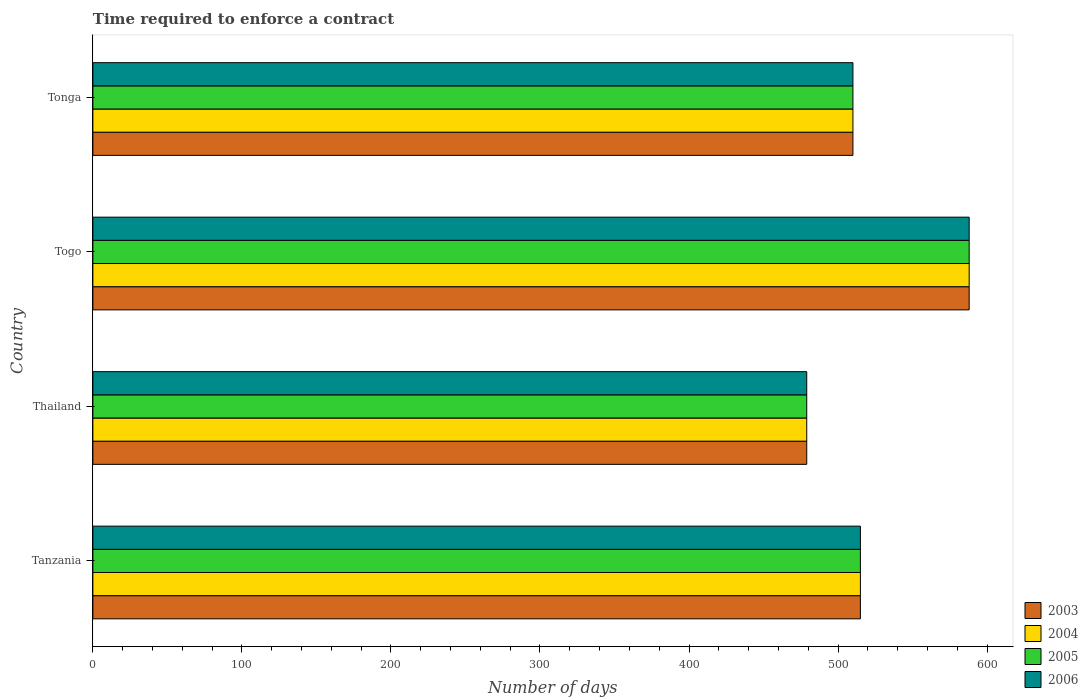Are the number of bars per tick equal to the number of legend labels?
Make the answer very short. Yes. How many bars are there on the 1st tick from the top?
Your answer should be very brief. 4. How many bars are there on the 3rd tick from the bottom?
Offer a terse response. 4. What is the label of the 1st group of bars from the top?
Ensure brevity in your answer.  Tonga. What is the number of days required to enforce a contract in 2003 in Togo?
Ensure brevity in your answer.  588. Across all countries, what is the maximum number of days required to enforce a contract in 2006?
Offer a terse response. 588. Across all countries, what is the minimum number of days required to enforce a contract in 2005?
Provide a short and direct response. 479. In which country was the number of days required to enforce a contract in 2005 maximum?
Offer a very short reply. Togo. In which country was the number of days required to enforce a contract in 2005 minimum?
Your response must be concise. Thailand. What is the total number of days required to enforce a contract in 2004 in the graph?
Provide a short and direct response. 2092. What is the average number of days required to enforce a contract in 2003 per country?
Offer a terse response. 523. What is the difference between the number of days required to enforce a contract in 2005 and number of days required to enforce a contract in 2004 in Tonga?
Keep it short and to the point. 0. What is the ratio of the number of days required to enforce a contract in 2006 in Tanzania to that in Tonga?
Your answer should be very brief. 1.01. Is the number of days required to enforce a contract in 2003 in Tanzania less than that in Thailand?
Make the answer very short. No. Is the difference between the number of days required to enforce a contract in 2005 in Tanzania and Tonga greater than the difference between the number of days required to enforce a contract in 2004 in Tanzania and Tonga?
Ensure brevity in your answer.  No. What is the difference between the highest and the lowest number of days required to enforce a contract in 2004?
Offer a very short reply. 109. In how many countries, is the number of days required to enforce a contract in 2004 greater than the average number of days required to enforce a contract in 2004 taken over all countries?
Your answer should be compact. 1. Is the sum of the number of days required to enforce a contract in 2006 in Togo and Tonga greater than the maximum number of days required to enforce a contract in 2005 across all countries?
Offer a terse response. Yes. Is it the case that in every country, the sum of the number of days required to enforce a contract in 2003 and number of days required to enforce a contract in 2006 is greater than the sum of number of days required to enforce a contract in 2004 and number of days required to enforce a contract in 2005?
Offer a very short reply. No. What does the 4th bar from the top in Tanzania represents?
Offer a terse response. 2003. What does the 3rd bar from the bottom in Tanzania represents?
Your response must be concise. 2005. Are all the bars in the graph horizontal?
Make the answer very short. Yes. How many countries are there in the graph?
Your answer should be compact. 4. What is the difference between two consecutive major ticks on the X-axis?
Your response must be concise. 100. Does the graph contain grids?
Give a very brief answer. No. Where does the legend appear in the graph?
Your answer should be compact. Bottom right. How many legend labels are there?
Provide a succinct answer. 4. What is the title of the graph?
Provide a succinct answer. Time required to enforce a contract. What is the label or title of the X-axis?
Your response must be concise. Number of days. What is the Number of days in 2003 in Tanzania?
Provide a succinct answer. 515. What is the Number of days in 2004 in Tanzania?
Ensure brevity in your answer.  515. What is the Number of days in 2005 in Tanzania?
Give a very brief answer. 515. What is the Number of days in 2006 in Tanzania?
Offer a very short reply. 515. What is the Number of days of 2003 in Thailand?
Your response must be concise. 479. What is the Number of days of 2004 in Thailand?
Your answer should be very brief. 479. What is the Number of days in 2005 in Thailand?
Your answer should be compact. 479. What is the Number of days in 2006 in Thailand?
Your answer should be compact. 479. What is the Number of days in 2003 in Togo?
Give a very brief answer. 588. What is the Number of days of 2004 in Togo?
Keep it short and to the point. 588. What is the Number of days in 2005 in Togo?
Make the answer very short. 588. What is the Number of days of 2006 in Togo?
Offer a terse response. 588. What is the Number of days in 2003 in Tonga?
Give a very brief answer. 510. What is the Number of days of 2004 in Tonga?
Provide a short and direct response. 510. What is the Number of days in 2005 in Tonga?
Your answer should be compact. 510. What is the Number of days in 2006 in Tonga?
Provide a succinct answer. 510. Across all countries, what is the maximum Number of days of 2003?
Offer a terse response. 588. Across all countries, what is the maximum Number of days of 2004?
Your answer should be compact. 588. Across all countries, what is the maximum Number of days of 2005?
Offer a terse response. 588. Across all countries, what is the maximum Number of days in 2006?
Your answer should be very brief. 588. Across all countries, what is the minimum Number of days of 2003?
Offer a very short reply. 479. Across all countries, what is the minimum Number of days of 2004?
Keep it short and to the point. 479. Across all countries, what is the minimum Number of days of 2005?
Your response must be concise. 479. Across all countries, what is the minimum Number of days of 2006?
Make the answer very short. 479. What is the total Number of days of 2003 in the graph?
Offer a terse response. 2092. What is the total Number of days in 2004 in the graph?
Offer a terse response. 2092. What is the total Number of days in 2005 in the graph?
Offer a terse response. 2092. What is the total Number of days of 2006 in the graph?
Provide a short and direct response. 2092. What is the difference between the Number of days in 2004 in Tanzania and that in Thailand?
Provide a succinct answer. 36. What is the difference between the Number of days in 2005 in Tanzania and that in Thailand?
Your response must be concise. 36. What is the difference between the Number of days in 2003 in Tanzania and that in Togo?
Your answer should be compact. -73. What is the difference between the Number of days in 2004 in Tanzania and that in Togo?
Ensure brevity in your answer.  -73. What is the difference between the Number of days of 2005 in Tanzania and that in Togo?
Your response must be concise. -73. What is the difference between the Number of days in 2006 in Tanzania and that in Togo?
Offer a very short reply. -73. What is the difference between the Number of days of 2003 in Tanzania and that in Tonga?
Your answer should be very brief. 5. What is the difference between the Number of days of 2004 in Tanzania and that in Tonga?
Provide a succinct answer. 5. What is the difference between the Number of days in 2005 in Tanzania and that in Tonga?
Keep it short and to the point. 5. What is the difference between the Number of days in 2006 in Tanzania and that in Tonga?
Make the answer very short. 5. What is the difference between the Number of days of 2003 in Thailand and that in Togo?
Ensure brevity in your answer.  -109. What is the difference between the Number of days in 2004 in Thailand and that in Togo?
Keep it short and to the point. -109. What is the difference between the Number of days in 2005 in Thailand and that in Togo?
Offer a terse response. -109. What is the difference between the Number of days of 2006 in Thailand and that in Togo?
Provide a short and direct response. -109. What is the difference between the Number of days of 2003 in Thailand and that in Tonga?
Provide a short and direct response. -31. What is the difference between the Number of days of 2004 in Thailand and that in Tonga?
Provide a succinct answer. -31. What is the difference between the Number of days of 2005 in Thailand and that in Tonga?
Your response must be concise. -31. What is the difference between the Number of days of 2006 in Thailand and that in Tonga?
Offer a very short reply. -31. What is the difference between the Number of days of 2004 in Togo and that in Tonga?
Provide a short and direct response. 78. What is the difference between the Number of days of 2005 in Togo and that in Tonga?
Ensure brevity in your answer.  78. What is the difference between the Number of days of 2003 in Tanzania and the Number of days of 2004 in Thailand?
Ensure brevity in your answer.  36. What is the difference between the Number of days in 2003 in Tanzania and the Number of days in 2005 in Thailand?
Your answer should be very brief. 36. What is the difference between the Number of days in 2003 in Tanzania and the Number of days in 2004 in Togo?
Make the answer very short. -73. What is the difference between the Number of days of 2003 in Tanzania and the Number of days of 2005 in Togo?
Your answer should be compact. -73. What is the difference between the Number of days of 2003 in Tanzania and the Number of days of 2006 in Togo?
Your answer should be very brief. -73. What is the difference between the Number of days in 2004 in Tanzania and the Number of days in 2005 in Togo?
Provide a succinct answer. -73. What is the difference between the Number of days in 2004 in Tanzania and the Number of days in 2006 in Togo?
Provide a succinct answer. -73. What is the difference between the Number of days in 2005 in Tanzania and the Number of days in 2006 in Togo?
Provide a succinct answer. -73. What is the difference between the Number of days in 2003 in Tanzania and the Number of days in 2004 in Tonga?
Make the answer very short. 5. What is the difference between the Number of days of 2003 in Tanzania and the Number of days of 2006 in Tonga?
Provide a succinct answer. 5. What is the difference between the Number of days in 2003 in Thailand and the Number of days in 2004 in Togo?
Ensure brevity in your answer.  -109. What is the difference between the Number of days of 2003 in Thailand and the Number of days of 2005 in Togo?
Give a very brief answer. -109. What is the difference between the Number of days in 2003 in Thailand and the Number of days in 2006 in Togo?
Offer a very short reply. -109. What is the difference between the Number of days of 2004 in Thailand and the Number of days of 2005 in Togo?
Make the answer very short. -109. What is the difference between the Number of days in 2004 in Thailand and the Number of days in 2006 in Togo?
Offer a terse response. -109. What is the difference between the Number of days in 2005 in Thailand and the Number of days in 2006 in Togo?
Ensure brevity in your answer.  -109. What is the difference between the Number of days in 2003 in Thailand and the Number of days in 2004 in Tonga?
Your answer should be compact. -31. What is the difference between the Number of days of 2003 in Thailand and the Number of days of 2005 in Tonga?
Make the answer very short. -31. What is the difference between the Number of days of 2003 in Thailand and the Number of days of 2006 in Tonga?
Keep it short and to the point. -31. What is the difference between the Number of days in 2004 in Thailand and the Number of days in 2005 in Tonga?
Ensure brevity in your answer.  -31. What is the difference between the Number of days of 2004 in Thailand and the Number of days of 2006 in Tonga?
Provide a short and direct response. -31. What is the difference between the Number of days in 2005 in Thailand and the Number of days in 2006 in Tonga?
Provide a short and direct response. -31. What is the difference between the Number of days in 2003 in Togo and the Number of days in 2004 in Tonga?
Your answer should be very brief. 78. What is the difference between the Number of days of 2004 in Togo and the Number of days of 2005 in Tonga?
Your answer should be very brief. 78. What is the difference between the Number of days of 2004 in Togo and the Number of days of 2006 in Tonga?
Your answer should be compact. 78. What is the average Number of days in 2003 per country?
Provide a succinct answer. 523. What is the average Number of days in 2004 per country?
Your answer should be very brief. 523. What is the average Number of days in 2005 per country?
Give a very brief answer. 523. What is the average Number of days of 2006 per country?
Offer a terse response. 523. What is the difference between the Number of days in 2003 and Number of days in 2005 in Tanzania?
Provide a succinct answer. 0. What is the difference between the Number of days of 2003 and Number of days of 2006 in Tanzania?
Your answer should be compact. 0. What is the difference between the Number of days of 2004 and Number of days of 2005 in Tanzania?
Keep it short and to the point. 0. What is the difference between the Number of days in 2004 and Number of days in 2006 in Tanzania?
Make the answer very short. 0. What is the difference between the Number of days in 2005 and Number of days in 2006 in Tanzania?
Your response must be concise. 0. What is the difference between the Number of days of 2003 and Number of days of 2004 in Thailand?
Offer a very short reply. 0. What is the difference between the Number of days in 2004 and Number of days in 2005 in Thailand?
Your answer should be compact. 0. What is the difference between the Number of days in 2004 and Number of days in 2006 in Thailand?
Provide a succinct answer. 0. What is the difference between the Number of days in 2005 and Number of days in 2006 in Thailand?
Ensure brevity in your answer.  0. What is the difference between the Number of days in 2003 and Number of days in 2005 in Togo?
Offer a very short reply. 0. What is the difference between the Number of days in 2003 and Number of days in 2006 in Togo?
Give a very brief answer. 0. What is the difference between the Number of days in 2003 and Number of days in 2004 in Tonga?
Provide a succinct answer. 0. What is the difference between the Number of days in 2003 and Number of days in 2005 in Tonga?
Keep it short and to the point. 0. What is the difference between the Number of days of 2004 and Number of days of 2005 in Tonga?
Make the answer very short. 0. What is the difference between the Number of days in 2004 and Number of days in 2006 in Tonga?
Your response must be concise. 0. What is the difference between the Number of days of 2005 and Number of days of 2006 in Tonga?
Give a very brief answer. 0. What is the ratio of the Number of days of 2003 in Tanzania to that in Thailand?
Your response must be concise. 1.08. What is the ratio of the Number of days of 2004 in Tanzania to that in Thailand?
Provide a short and direct response. 1.08. What is the ratio of the Number of days of 2005 in Tanzania to that in Thailand?
Offer a very short reply. 1.08. What is the ratio of the Number of days of 2006 in Tanzania to that in Thailand?
Provide a succinct answer. 1.08. What is the ratio of the Number of days in 2003 in Tanzania to that in Togo?
Give a very brief answer. 0.88. What is the ratio of the Number of days in 2004 in Tanzania to that in Togo?
Make the answer very short. 0.88. What is the ratio of the Number of days in 2005 in Tanzania to that in Togo?
Keep it short and to the point. 0.88. What is the ratio of the Number of days of 2006 in Tanzania to that in Togo?
Offer a very short reply. 0.88. What is the ratio of the Number of days in 2003 in Tanzania to that in Tonga?
Your answer should be compact. 1.01. What is the ratio of the Number of days in 2004 in Tanzania to that in Tonga?
Ensure brevity in your answer.  1.01. What is the ratio of the Number of days of 2005 in Tanzania to that in Tonga?
Keep it short and to the point. 1.01. What is the ratio of the Number of days in 2006 in Tanzania to that in Tonga?
Offer a terse response. 1.01. What is the ratio of the Number of days of 2003 in Thailand to that in Togo?
Your answer should be compact. 0.81. What is the ratio of the Number of days of 2004 in Thailand to that in Togo?
Offer a very short reply. 0.81. What is the ratio of the Number of days of 2005 in Thailand to that in Togo?
Keep it short and to the point. 0.81. What is the ratio of the Number of days in 2006 in Thailand to that in Togo?
Your answer should be very brief. 0.81. What is the ratio of the Number of days in 2003 in Thailand to that in Tonga?
Keep it short and to the point. 0.94. What is the ratio of the Number of days of 2004 in Thailand to that in Tonga?
Provide a short and direct response. 0.94. What is the ratio of the Number of days in 2005 in Thailand to that in Tonga?
Provide a succinct answer. 0.94. What is the ratio of the Number of days in 2006 in Thailand to that in Tonga?
Offer a very short reply. 0.94. What is the ratio of the Number of days of 2003 in Togo to that in Tonga?
Ensure brevity in your answer.  1.15. What is the ratio of the Number of days of 2004 in Togo to that in Tonga?
Offer a terse response. 1.15. What is the ratio of the Number of days of 2005 in Togo to that in Tonga?
Your response must be concise. 1.15. What is the ratio of the Number of days of 2006 in Togo to that in Tonga?
Offer a very short reply. 1.15. What is the difference between the highest and the second highest Number of days in 2004?
Your answer should be compact. 73. What is the difference between the highest and the second highest Number of days of 2006?
Your answer should be very brief. 73. What is the difference between the highest and the lowest Number of days of 2003?
Your answer should be very brief. 109. What is the difference between the highest and the lowest Number of days in 2004?
Your answer should be compact. 109. What is the difference between the highest and the lowest Number of days in 2005?
Your answer should be compact. 109. What is the difference between the highest and the lowest Number of days of 2006?
Make the answer very short. 109. 